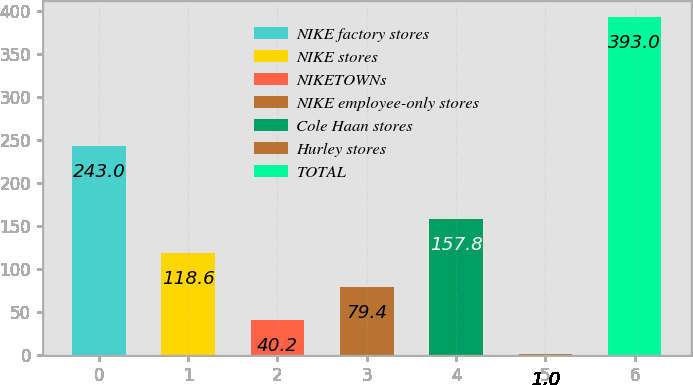<chart> <loc_0><loc_0><loc_500><loc_500><bar_chart><fcel>NIKE factory stores<fcel>NIKE stores<fcel>NIKETOWNs<fcel>NIKE employee-only stores<fcel>Cole Haan stores<fcel>Hurley stores<fcel>TOTAL<nl><fcel>243<fcel>118.6<fcel>40.2<fcel>79.4<fcel>157.8<fcel>1<fcel>393<nl></chart> 